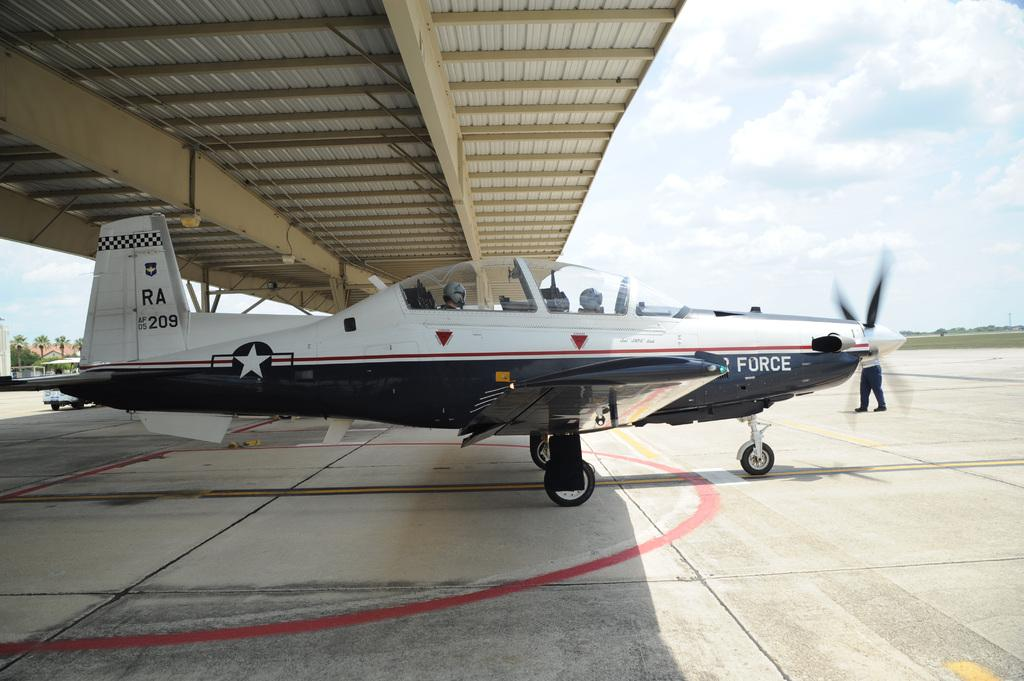<image>
Provide a brief description of the given image. Airplane from air force about to fly from off the ground 